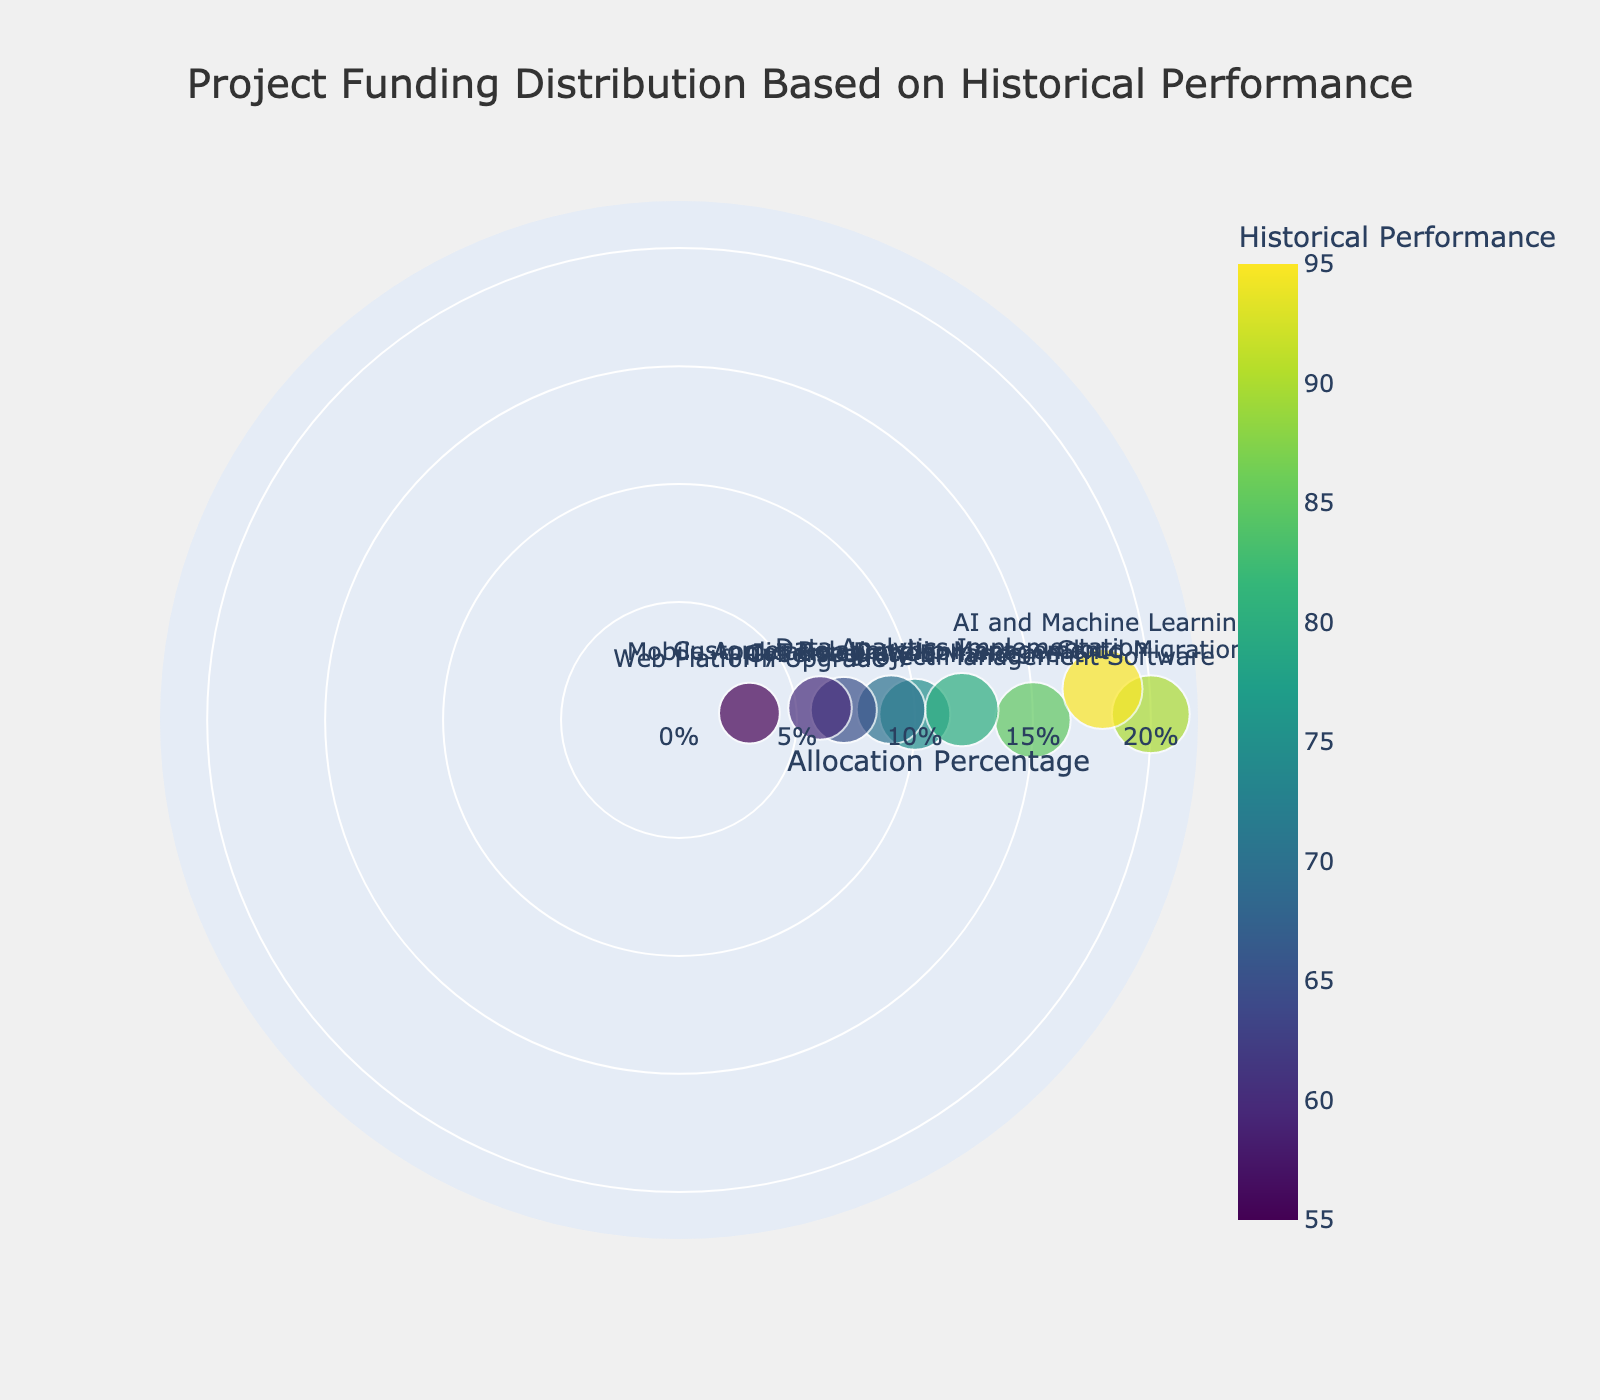What is the title of the figure? The title is usually found at the top of the figure. For this figure, it clearly displays the project title, "Project Funding Distribution Based on Historical Performance".
Answer: Project Funding Distribution Based on Historical Performance How many projects are represented in the figure? Count the number of points (data markers) on the polar scatter plot, each representing a project.
Answer: 9 Which project has the highest allocation percentage? Identify the data point farthest from the center along the radial axis, as it corresponds to the highest allocation percentage. The hovertext can help confirm this.
Answer: Cloud Migration Which project has the lowest allocation percentage? Identify the data point closest to the center along the radial axis, indicating the lowest allocation percentage. Use the hovertext for confirmation.
Answer: Web Platform Upgrade How does the Historical Performance metric affect the marker size in the figure? Observe that larger marker sizes correlate with higher historical performance values, and the hovertext provides specific values for each project.
Answer: Larger markers have higher Historical Performance values Does the project with the highest allocation also have the highest historical performance? Compare the two projects in terms of their allocation and performance metrics using the hovertext. Cloud Migration has the highest allocation, but AI and Machine Learning has the highest performance.
Answer: No What is the average allocation percentage across all projects? Sum all allocation percentages and divide by the total number of projects. Calculation: (15 + 20 + 10 + 12 + 9 + 7 + 18 + 6 + 3) / 9 = 100 / 9 ≈ 11.11
Answer: 11.11% What is the difference in historical performance between the IoT Integration and AI and Machine Learning projects? Subtract the Historical Performance value of IoT Integration from that of AI and Machine Learning using the hovertext. Calculation: 95 - 65.
Answer: 30 Which projects have a Historical Performance metric lower than 70? Identify the projects with Historical Performance values below 70 by examining marker sizes and using hovertext for precise confirmation.
Answer: Customer Relationship Management, IoT Integration, Mobile Application Development, Web Platform Upgrade Is there a positive correlation between Allocation Percentage and Historical Performance? To determine the correlation, visually assess whether higher allocation percentages (radial distance) generally align with larger marker sizes (higher historical performance). Higher performance does tend to correspond with higher allocation.
Answer: Yes 